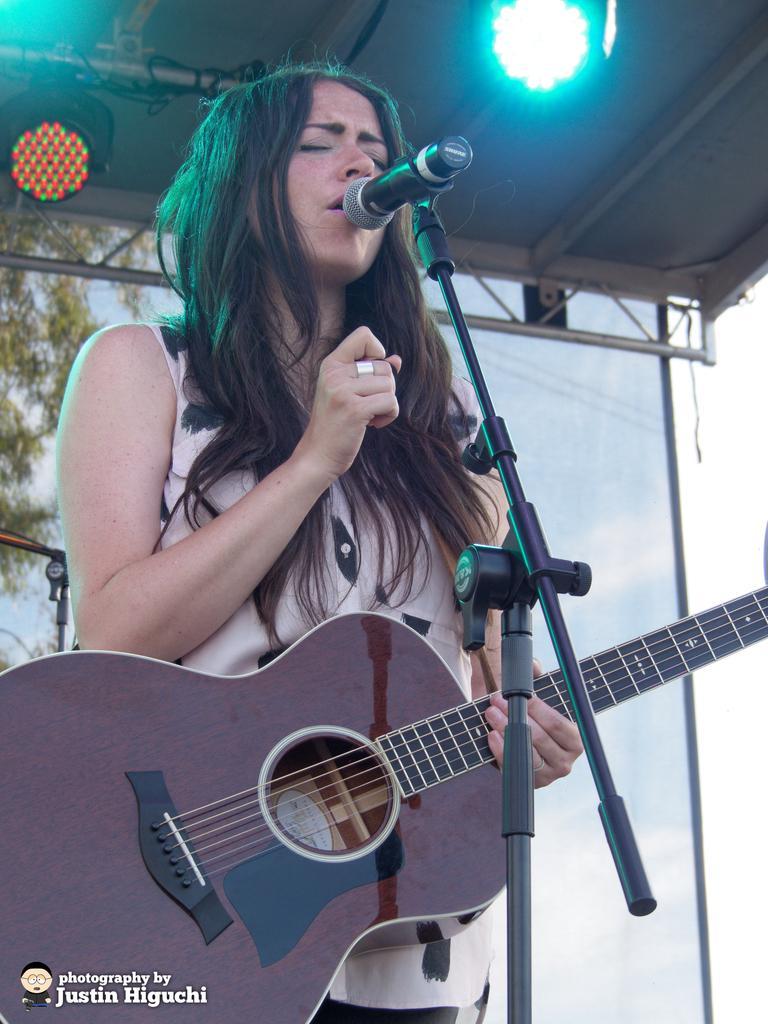Can you describe this image briefly? One lady is standing and she is holding a guitar. In front of her a mic stand with mic is there. She is singing. In the background we can see a branch of a tree. And above her there is a light. 